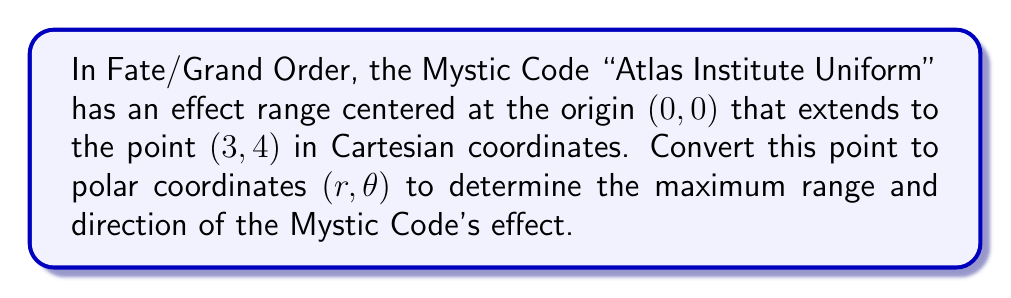What is the answer to this math problem? To convert the Cartesian coordinates (3, 4) to polar coordinates $(r, \theta)$, we need to follow these steps:

1. Calculate $r$:
   $r$ represents the distance from the origin to the point. We can use the Pythagorean theorem:
   $$r = \sqrt{x^2 + y^2} = \sqrt{3^2 + 4^2} = \sqrt{9 + 16} = \sqrt{25} = 5$$

2. Calculate $\theta$:
   $\theta$ represents the angle from the positive x-axis to the line from the origin to the point.
   We can use the arctangent function:
   $$\theta = \arctan(\frac{y}{x}) = \arctan(\frac{4}{3})$$

   However, we need to be careful with the arctangent function, as it only gives values between $-\frac{\pi}{2}$ and $\frac{\pi}{2}$. Since both x and y are positive in this case, we're in the first quadrant, so we can use the arctangent directly:

   $$\theta = \arctan(\frac{4}{3}) \approx 0.9273 \text{ radians}$$

   To convert to degrees:
   $$\theta \approx 0.9273 \times \frac{180^{\circ}}{\pi} \approx 53.13^{\circ}$$

[asy]
import geometry;

size(200);
draw((-1,0)--(5,0), arrow=Arrow);
draw((0,-1)--(0,5), arrow=Arrow);
draw((0,0)--(3,4), arrow=Arrow);
dot((3,4));
draw(arc((0,0), 1, 0, 53.13), L="$\theta$");
label("(3, 4)", (3,4), NE);
label("$r$", (1.5,2), NW);
[/asy]

Therefore, the polar coordinates are $(5, 0.9273)$ in radians or $(5, 53.13^{\circ})$ in degrees.
Answer: $(5, 0.9273)$ radians or $(5, 53.13^{\circ})$ 